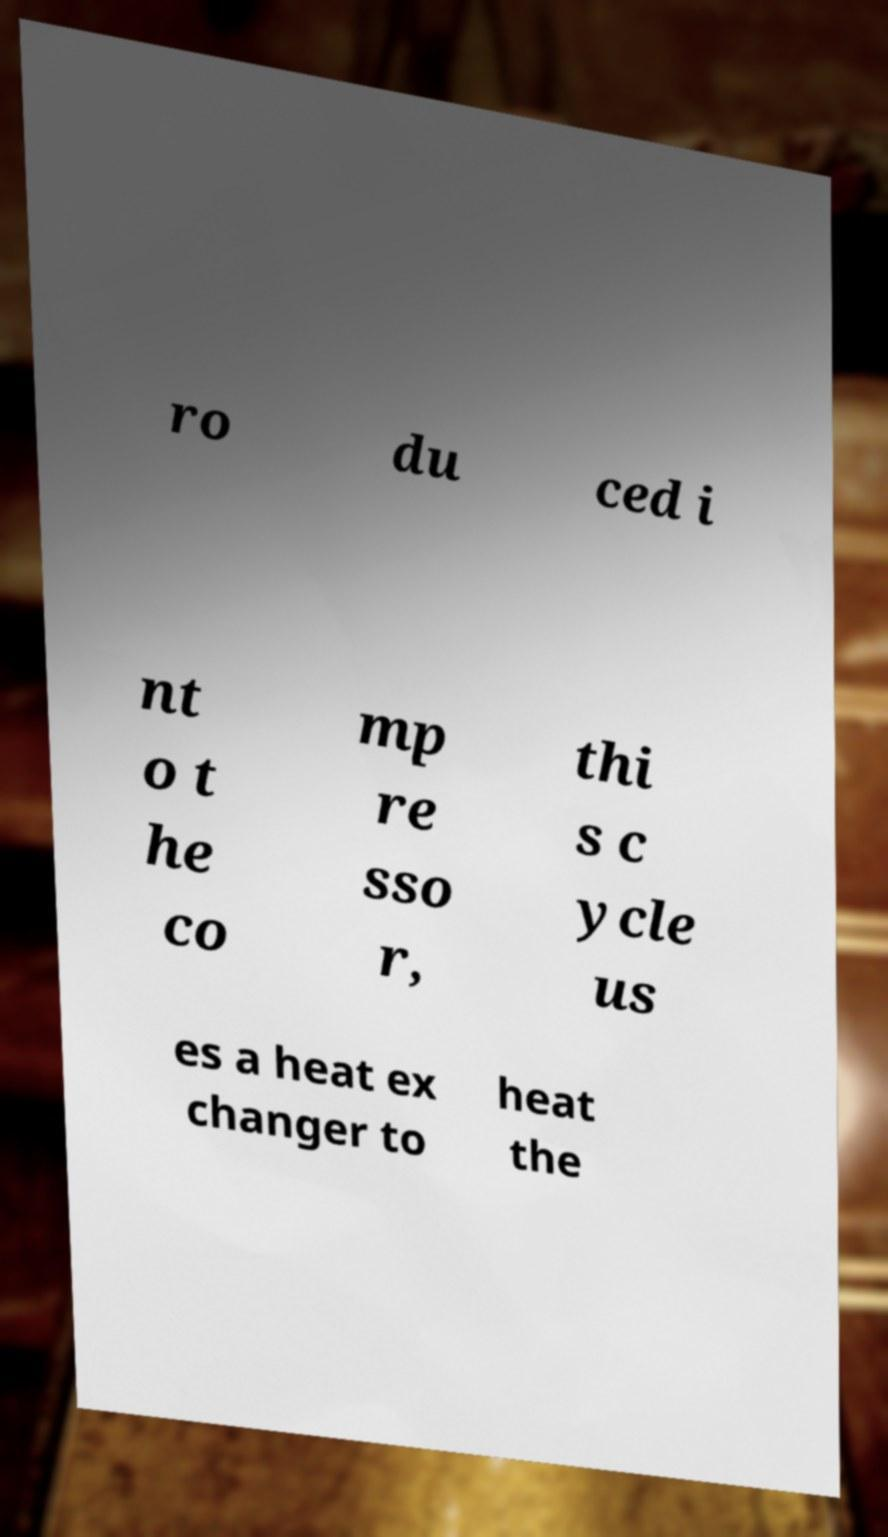Please read and relay the text visible in this image. What does it say? ro du ced i nt o t he co mp re sso r, thi s c ycle us es a heat ex changer to heat the 